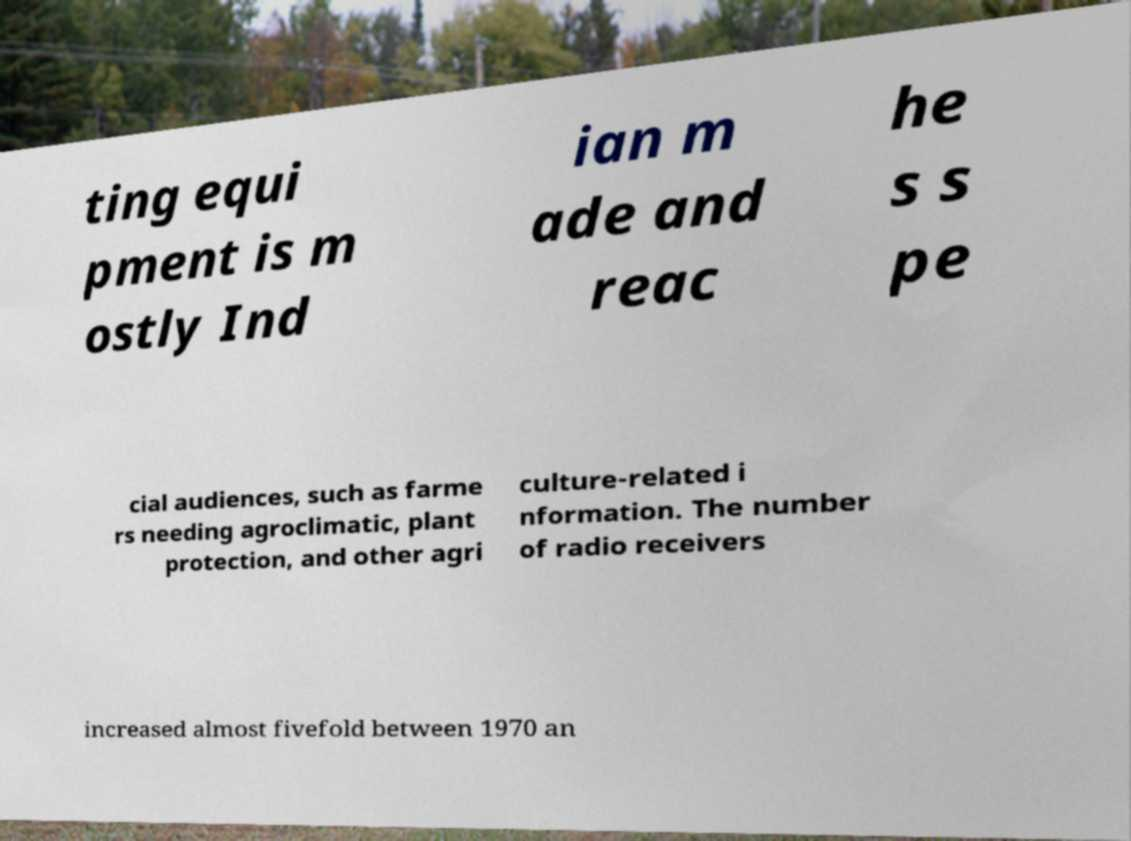Please identify and transcribe the text found in this image. ting equi pment is m ostly Ind ian m ade and reac he s s pe cial audiences, such as farme rs needing agroclimatic, plant protection, and other agri culture-related i nformation. The number of radio receivers increased almost fivefold between 1970 an 